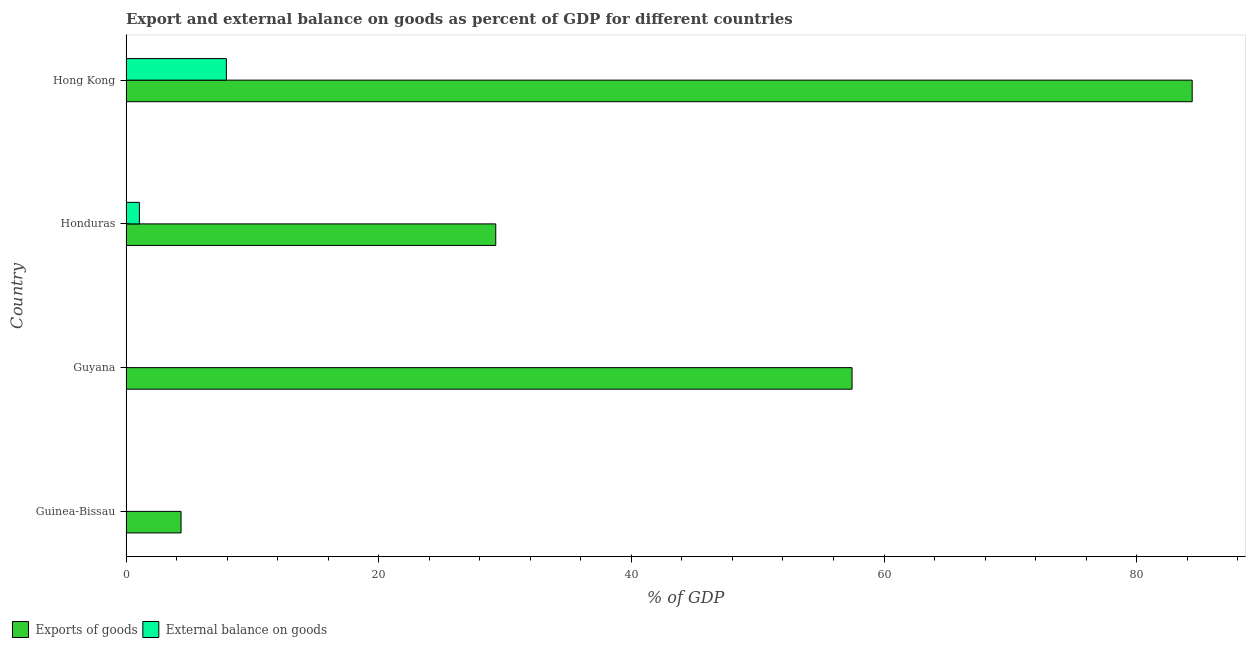How many different coloured bars are there?
Your response must be concise. 2. What is the label of the 3rd group of bars from the top?
Ensure brevity in your answer.  Guyana. What is the export of goods as percentage of gdp in Guyana?
Offer a terse response. 57.47. Across all countries, what is the maximum export of goods as percentage of gdp?
Keep it short and to the point. 84.39. In which country was the export of goods as percentage of gdp maximum?
Keep it short and to the point. Hong Kong. What is the total external balance on goods as percentage of gdp in the graph?
Give a very brief answer. 9. What is the difference between the export of goods as percentage of gdp in Honduras and that in Hong Kong?
Offer a terse response. -55.12. What is the difference between the export of goods as percentage of gdp in Guyana and the external balance on goods as percentage of gdp in Hong Kong?
Make the answer very short. 49.52. What is the average external balance on goods as percentage of gdp per country?
Offer a very short reply. 2.25. What is the difference between the external balance on goods as percentage of gdp and export of goods as percentage of gdp in Hong Kong?
Your answer should be very brief. -76.44. In how many countries, is the export of goods as percentage of gdp greater than 56 %?
Give a very brief answer. 2. What is the ratio of the export of goods as percentage of gdp in Guinea-Bissau to that in Hong Kong?
Keep it short and to the point. 0.05. What is the difference between the highest and the second highest export of goods as percentage of gdp?
Your response must be concise. 26.92. What is the difference between the highest and the lowest external balance on goods as percentage of gdp?
Your answer should be very brief. 7.94. Are all the bars in the graph horizontal?
Keep it short and to the point. Yes. How many countries are there in the graph?
Provide a succinct answer. 4. What is the difference between two consecutive major ticks on the X-axis?
Make the answer very short. 20. Does the graph contain any zero values?
Provide a short and direct response. Yes. Where does the legend appear in the graph?
Your answer should be compact. Bottom left. How many legend labels are there?
Ensure brevity in your answer.  2. What is the title of the graph?
Keep it short and to the point. Export and external balance on goods as percent of GDP for different countries. Does "From World Bank" appear as one of the legend labels in the graph?
Your answer should be compact. No. What is the label or title of the X-axis?
Provide a short and direct response. % of GDP. What is the % of GDP in Exports of goods in Guinea-Bissau?
Ensure brevity in your answer.  4.36. What is the % of GDP in External balance on goods in Guinea-Bissau?
Keep it short and to the point. 0. What is the % of GDP in Exports of goods in Guyana?
Make the answer very short. 57.47. What is the % of GDP of Exports of goods in Honduras?
Provide a short and direct response. 29.27. What is the % of GDP of External balance on goods in Honduras?
Keep it short and to the point. 1.06. What is the % of GDP in Exports of goods in Hong Kong?
Offer a terse response. 84.39. What is the % of GDP in External balance on goods in Hong Kong?
Provide a short and direct response. 7.94. Across all countries, what is the maximum % of GDP of Exports of goods?
Keep it short and to the point. 84.39. Across all countries, what is the maximum % of GDP of External balance on goods?
Make the answer very short. 7.94. Across all countries, what is the minimum % of GDP in Exports of goods?
Make the answer very short. 4.36. Across all countries, what is the minimum % of GDP of External balance on goods?
Provide a short and direct response. 0. What is the total % of GDP in Exports of goods in the graph?
Your response must be concise. 175.48. What is the total % of GDP in External balance on goods in the graph?
Make the answer very short. 9. What is the difference between the % of GDP of Exports of goods in Guinea-Bissau and that in Guyana?
Provide a succinct answer. -53.11. What is the difference between the % of GDP in Exports of goods in Guinea-Bissau and that in Honduras?
Keep it short and to the point. -24.91. What is the difference between the % of GDP of Exports of goods in Guinea-Bissau and that in Hong Kong?
Provide a succinct answer. -80.03. What is the difference between the % of GDP of Exports of goods in Guyana and that in Honduras?
Provide a short and direct response. 28.2. What is the difference between the % of GDP in Exports of goods in Guyana and that in Hong Kong?
Provide a short and direct response. -26.92. What is the difference between the % of GDP of Exports of goods in Honduras and that in Hong Kong?
Offer a very short reply. -55.12. What is the difference between the % of GDP of External balance on goods in Honduras and that in Hong Kong?
Ensure brevity in your answer.  -6.89. What is the difference between the % of GDP of Exports of goods in Guinea-Bissau and the % of GDP of External balance on goods in Honduras?
Keep it short and to the point. 3.3. What is the difference between the % of GDP of Exports of goods in Guinea-Bissau and the % of GDP of External balance on goods in Hong Kong?
Your answer should be very brief. -3.59. What is the difference between the % of GDP of Exports of goods in Guyana and the % of GDP of External balance on goods in Honduras?
Offer a terse response. 56.41. What is the difference between the % of GDP in Exports of goods in Guyana and the % of GDP in External balance on goods in Hong Kong?
Offer a very short reply. 49.52. What is the difference between the % of GDP in Exports of goods in Honduras and the % of GDP in External balance on goods in Hong Kong?
Provide a short and direct response. 21.32. What is the average % of GDP in Exports of goods per country?
Keep it short and to the point. 43.87. What is the average % of GDP in External balance on goods per country?
Offer a very short reply. 2.25. What is the difference between the % of GDP in Exports of goods and % of GDP in External balance on goods in Honduras?
Your response must be concise. 28.21. What is the difference between the % of GDP in Exports of goods and % of GDP in External balance on goods in Hong Kong?
Your response must be concise. 76.44. What is the ratio of the % of GDP in Exports of goods in Guinea-Bissau to that in Guyana?
Offer a terse response. 0.08. What is the ratio of the % of GDP in Exports of goods in Guinea-Bissau to that in Honduras?
Your answer should be very brief. 0.15. What is the ratio of the % of GDP of Exports of goods in Guinea-Bissau to that in Hong Kong?
Offer a terse response. 0.05. What is the ratio of the % of GDP in Exports of goods in Guyana to that in Honduras?
Provide a succinct answer. 1.96. What is the ratio of the % of GDP in Exports of goods in Guyana to that in Hong Kong?
Provide a short and direct response. 0.68. What is the ratio of the % of GDP of Exports of goods in Honduras to that in Hong Kong?
Keep it short and to the point. 0.35. What is the ratio of the % of GDP in External balance on goods in Honduras to that in Hong Kong?
Offer a terse response. 0.13. What is the difference between the highest and the second highest % of GDP in Exports of goods?
Your answer should be very brief. 26.92. What is the difference between the highest and the lowest % of GDP of Exports of goods?
Offer a very short reply. 80.03. What is the difference between the highest and the lowest % of GDP in External balance on goods?
Give a very brief answer. 7.94. 